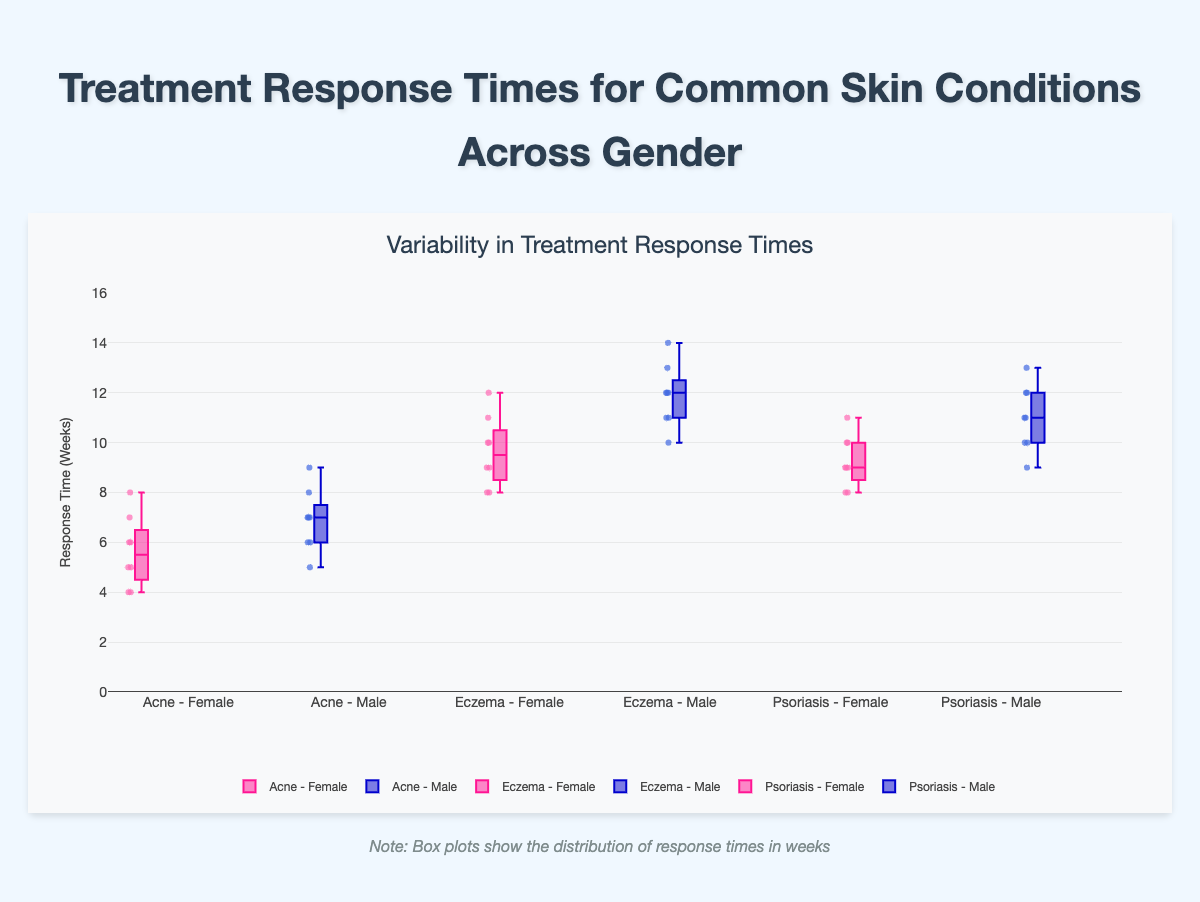What is the title of the figure? The title is displayed at the top middle of the figure and usually describes the content of the figure. Here, it's "Variability in Treatment Response Times".
Answer: Variability in Treatment Response Times What is the response time range on the y-axis? The y-axis, titled 'Response Time (Weeks)', has a range that can be observed from the tick marks. The range shown is from 0 to 16 weeks.
Answer: 0 to 16 weeks Which skin condition has the shortest median response time for females? For females, we need to look at the median line within each box plot for Acne, Eczema, and Psoriasis. The shortest median line is seen in Acne.
Answer: Acne Do males or females have a longer maximum response time for Eczema? The maximum response time is indicated by the whisker (the line extending from the box). For Eczema, the male whisker reaches up to 14 weeks, while the female whisker reaches up to 12 weeks. Therefore, males have the longer maximum response time.
Answer: Males Compare the interquartile ranges (IQR) of response times for Acne between genders. Which one is wider? The IQR is the range between the first quartile (Q1) and the third quartile (Q3). For Acne, the IQR for females is between 4 and 7 weeks, and for males, it is between 6 and 8 weeks. The IQR for males is narrower than that for females.
Answer: Females What is the median response time for males with Psoriasis? The median response time is represented by the line within the box. For males with Psoriasis, this median line is at 11 weeks.
Answer: 11 weeks Which skin condition shows the widest overall range of response times for females? The overall range can be determined by the length of the whiskers extending from the box plot. For females, Eczema has the widest range, from 8 to 12 weeks.
Answer: Eczema Are there any outliers in any of the response time distributions? Outliers would be indicated by points outside the whiskers of the box plots. No such points are present in any of the response time distributions, indicating no outliers.
Answer: No Compare the median response times for males across all three skin conditions. Which has the longest and which has the shortest? The median response times for males can be identified by the lines within each box plot. For Acne, it is 7 weeks; for Eczema, it is 12 weeks; and for Psoriasis, it is 11 weeks. Therefore, Eczema has the longest median response time, and Acne has the shortest.
Answer: Longest: Eczema, Shortest: Acne 